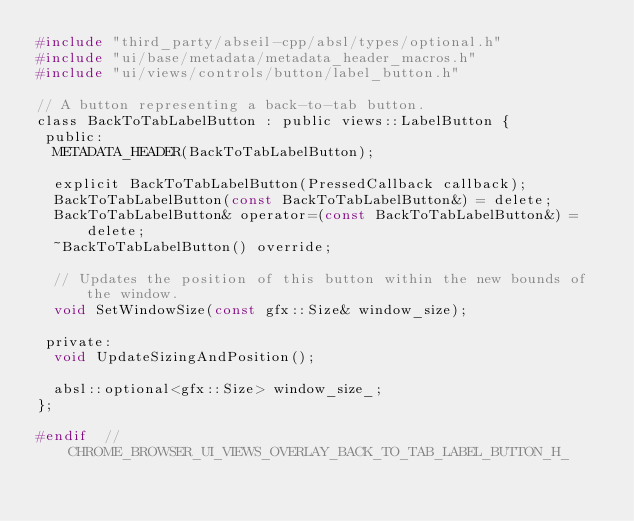Convert code to text. <code><loc_0><loc_0><loc_500><loc_500><_C_>#include "third_party/abseil-cpp/absl/types/optional.h"
#include "ui/base/metadata/metadata_header_macros.h"
#include "ui/views/controls/button/label_button.h"

// A button representing a back-to-tab button.
class BackToTabLabelButton : public views::LabelButton {
 public:
  METADATA_HEADER(BackToTabLabelButton);

  explicit BackToTabLabelButton(PressedCallback callback);
  BackToTabLabelButton(const BackToTabLabelButton&) = delete;
  BackToTabLabelButton& operator=(const BackToTabLabelButton&) = delete;
  ~BackToTabLabelButton() override;

  // Updates the position of this button within the new bounds of the window.
  void SetWindowSize(const gfx::Size& window_size);

 private:
  void UpdateSizingAndPosition();

  absl::optional<gfx::Size> window_size_;
};

#endif  // CHROME_BROWSER_UI_VIEWS_OVERLAY_BACK_TO_TAB_LABEL_BUTTON_H_
</code> 